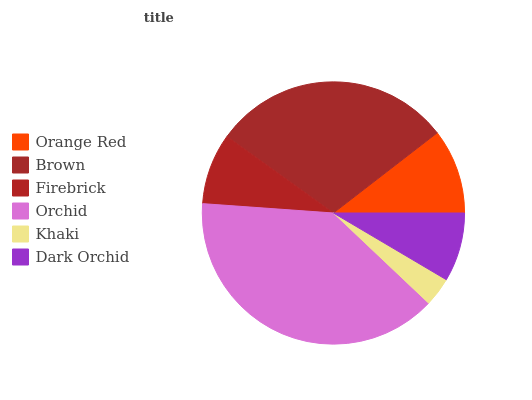Is Khaki the minimum?
Answer yes or no. Yes. Is Orchid the maximum?
Answer yes or no. Yes. Is Brown the minimum?
Answer yes or no. No. Is Brown the maximum?
Answer yes or no. No. Is Brown greater than Orange Red?
Answer yes or no. Yes. Is Orange Red less than Brown?
Answer yes or no. Yes. Is Orange Red greater than Brown?
Answer yes or no. No. Is Brown less than Orange Red?
Answer yes or no. No. Is Orange Red the high median?
Answer yes or no. Yes. Is Firebrick the low median?
Answer yes or no. Yes. Is Khaki the high median?
Answer yes or no. No. Is Orchid the low median?
Answer yes or no. No. 